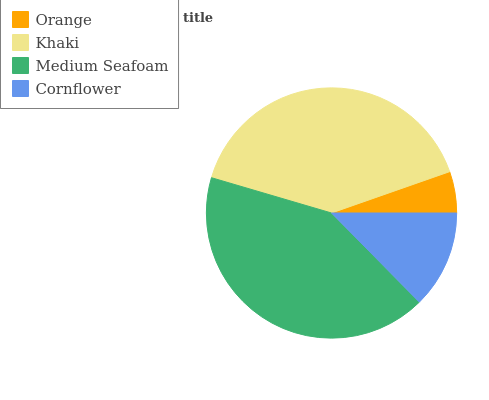Is Orange the minimum?
Answer yes or no. Yes. Is Medium Seafoam the maximum?
Answer yes or no. Yes. Is Khaki the minimum?
Answer yes or no. No. Is Khaki the maximum?
Answer yes or no. No. Is Khaki greater than Orange?
Answer yes or no. Yes. Is Orange less than Khaki?
Answer yes or no. Yes. Is Orange greater than Khaki?
Answer yes or no. No. Is Khaki less than Orange?
Answer yes or no. No. Is Khaki the high median?
Answer yes or no. Yes. Is Cornflower the low median?
Answer yes or no. Yes. Is Cornflower the high median?
Answer yes or no. No. Is Medium Seafoam the low median?
Answer yes or no. No. 